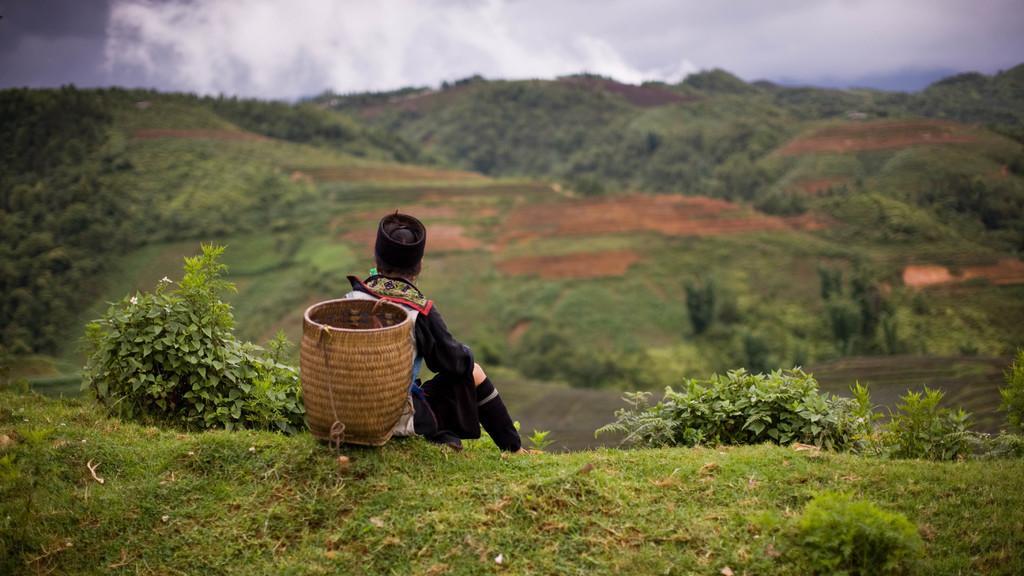Describe this image in one or two sentences. in this image I see a person who is sitting on the grass and the person is also carrying a basket which is of brown in color and the person is also wearing a cap which is of black in color and there are plants beside the person and in the background there are lots of plants and on top the sky seems to be pretty clear. 